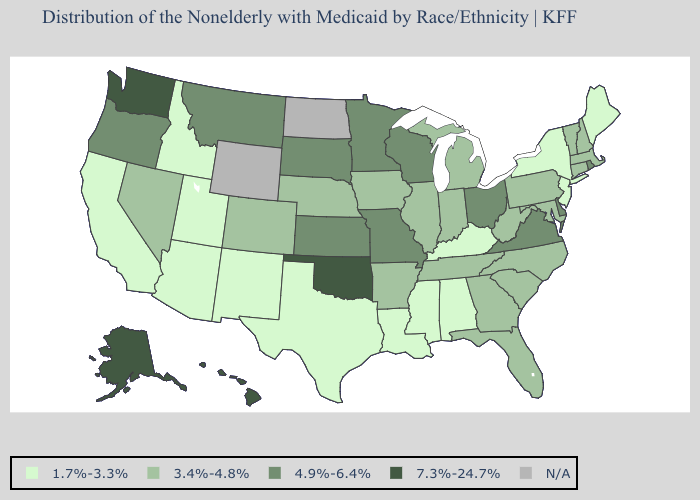What is the value of Louisiana?
Give a very brief answer. 1.7%-3.3%. Name the states that have a value in the range 7.3%-24.7%?
Keep it brief. Alaska, Hawaii, Oklahoma, Washington. What is the value of Nebraska?
Keep it brief. 3.4%-4.8%. Name the states that have a value in the range 4.9%-6.4%?
Keep it brief. Delaware, Kansas, Minnesota, Missouri, Montana, Ohio, Oregon, Rhode Island, South Dakota, Virginia, Wisconsin. What is the highest value in the West ?
Short answer required. 7.3%-24.7%. Name the states that have a value in the range N/A?
Be succinct. North Dakota, Wyoming. Does the first symbol in the legend represent the smallest category?
Quick response, please. Yes. Name the states that have a value in the range N/A?
Answer briefly. North Dakota, Wyoming. What is the highest value in states that border Missouri?
Write a very short answer. 7.3%-24.7%. What is the value of New Hampshire?
Quick response, please. 3.4%-4.8%. Name the states that have a value in the range 4.9%-6.4%?
Short answer required. Delaware, Kansas, Minnesota, Missouri, Montana, Ohio, Oregon, Rhode Island, South Dakota, Virginia, Wisconsin. What is the value of Utah?
Concise answer only. 1.7%-3.3%. Does Ohio have the highest value in the USA?
Write a very short answer. No. What is the value of Texas?
Short answer required. 1.7%-3.3%. Name the states that have a value in the range 4.9%-6.4%?
Quick response, please. Delaware, Kansas, Minnesota, Missouri, Montana, Ohio, Oregon, Rhode Island, South Dakota, Virginia, Wisconsin. 